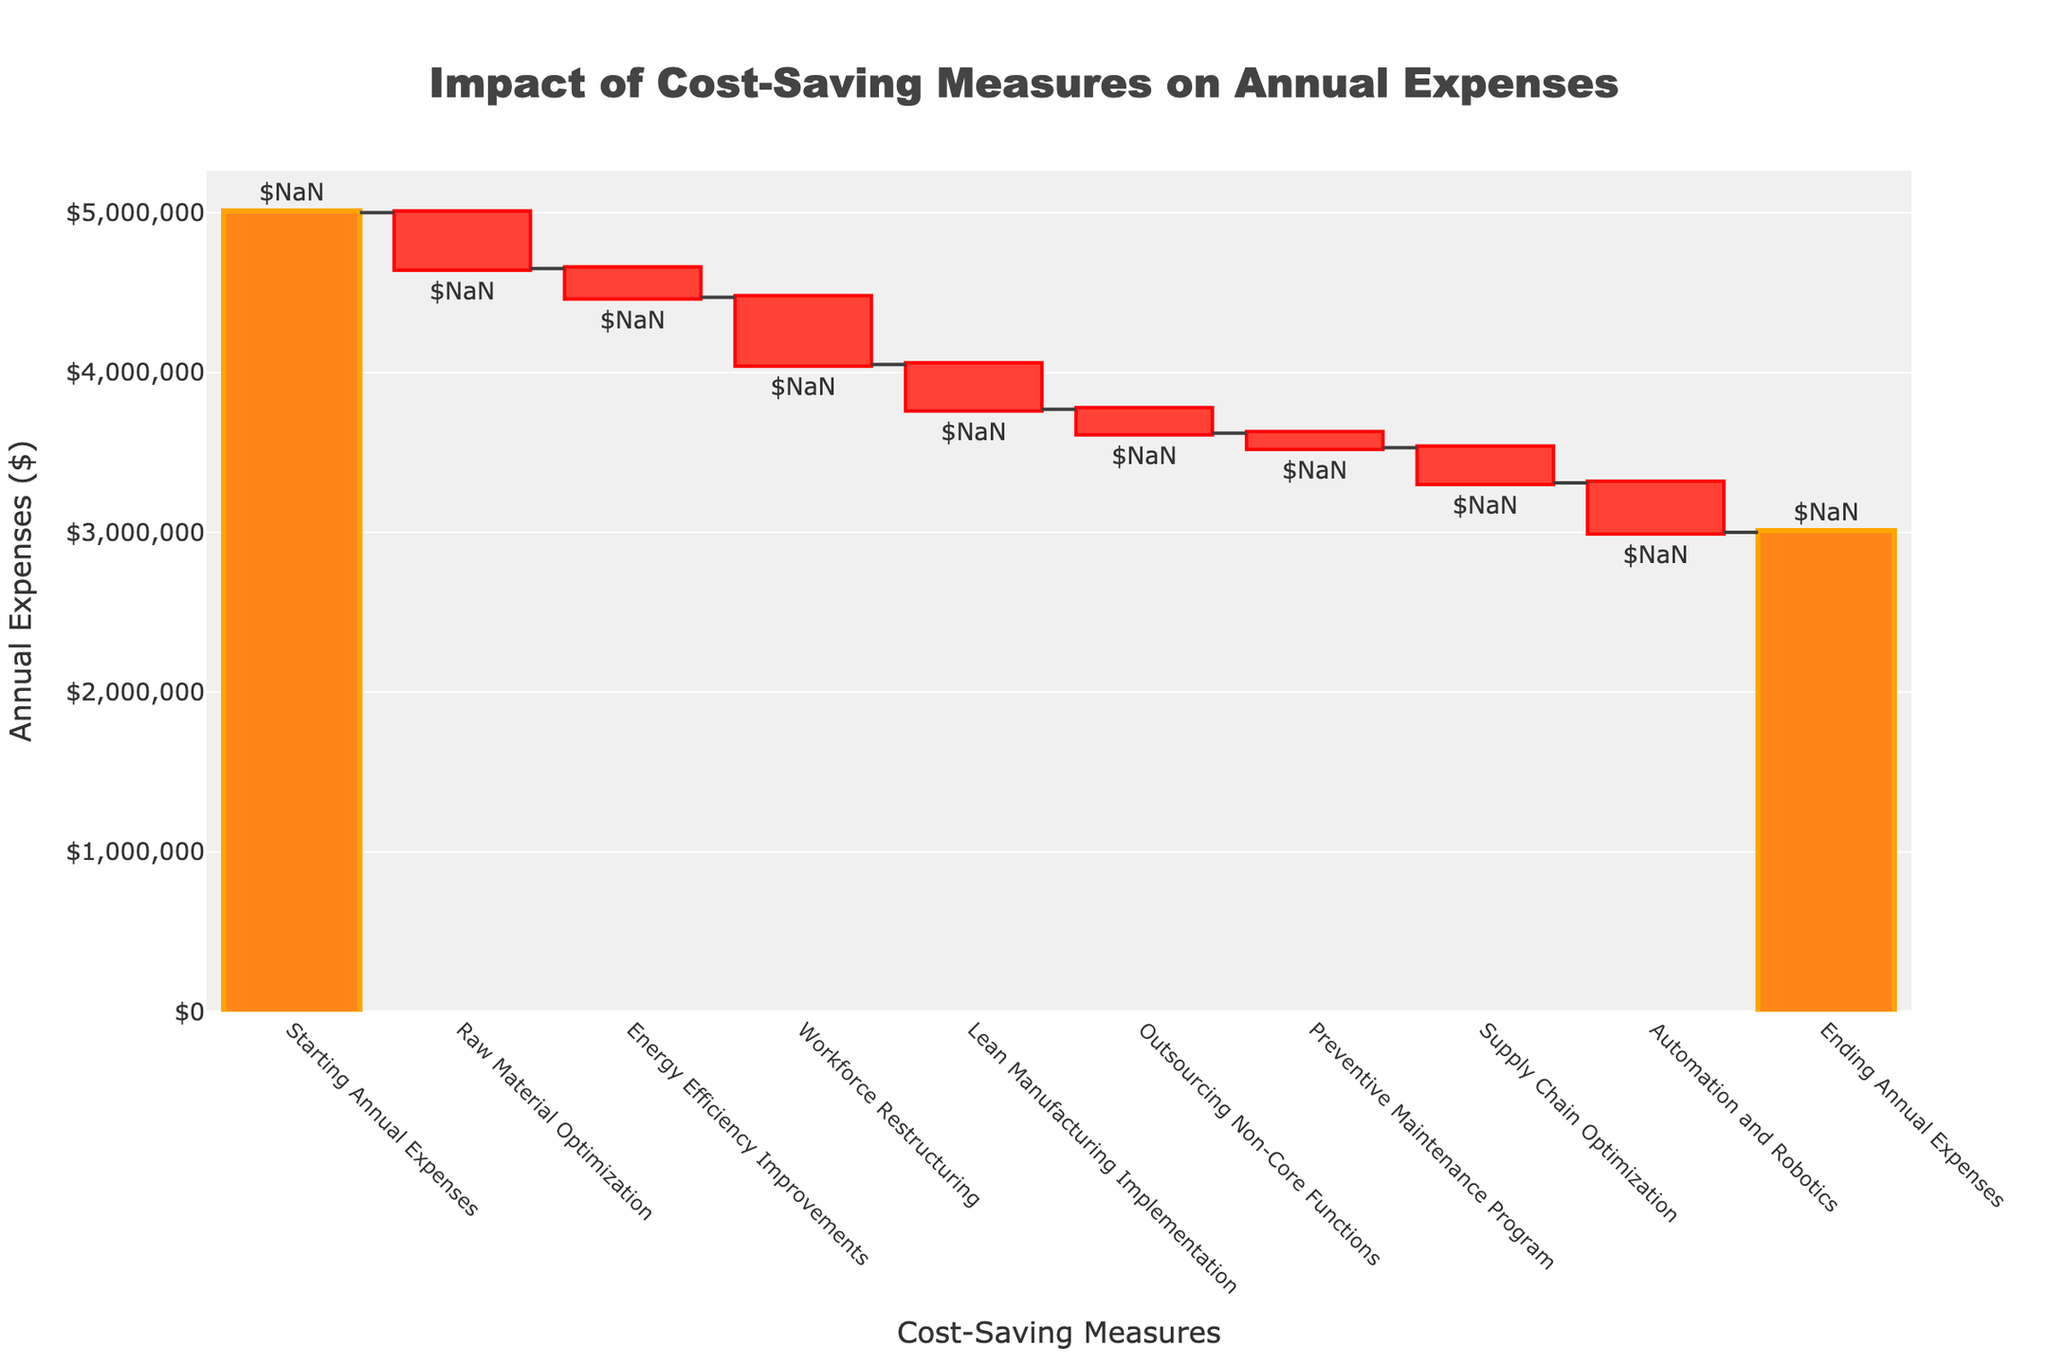what is the title of the chart? The chart title is typically placed at the top of the figure and specifies the purpose or content of the chart. In this case, the title as given is "Impact of Cost-Saving Measures on Annual Expenses."
Answer: "Impact of Cost-Saving Measures on Annual Expenses" What does the first bar represent? In Waterfall Charts, the first bar usually represents the starting value or initial amount, which in this case is titled "Starting Annual Expenses" and amounts to $5,000,000.
Answer: Starting Annual Expenses $5,000,000 Which cost-saving measure has the highest impact? To determine the highest impact, observe which bar has the largest negative value. "Raw Material Optimization" has the largest negative value with a reduction of $350,000.
Answer: Raw Material Optimization What is the total reduction in expenses due to "Energy Efficiency Improvements" and "Supply Chain Optimization"? Add the expenses reduced by "Energy Efficiency Improvements" ($180,000) and "Supply Chain Optimization" ($220,000).
Answer: $400,000 By how much did the "Automation and Robotics" measure reduce the annual expenses? The bar labeled "Automation and Robotics" shows a reduction in expenses. The exact amount noted is $310,000.
Answer: $310,000 How much are the Ending Annual Expenses represented by the last bar? The last bar represents the Ending Annual Expenses which, according to the figure, is $3,000,000.
Answer: $3,000,000 Are the total cost savings greater than or less than $2,000,000? Sum the values of all the negative contributions to see if they are greater than $2,000,000: -$350,000 - $180,000 - $420,000 - $280,000 - $150,000 - $90,000 - $220,000 - $310,000 = -$2,000,000. However, it's noted that cumulatively, the total cost-saving measures add up to reduce the expenses from $5,000,000 to $3,000,000, implying a total saving of $2,000,000.
Answer: $2,000,000 How many cost-saving measures are represented in the chart? Count the number of bars representing cost-saving measures. Exclude the starting and ending bars: Raw Material Optimization, Energy Efficiency Improvements, Workforce Restructuring, Lean Manufacturing Implementation, Outsourcing Non-Core Functions, Preventive Maintenance Program, Supply Chain Optimization, Automation and Robotics. There are 8 measures.
Answer: 8 How does "Lean Manufacturing Implementation" compare to "Outsourcing Non-Core Functions" in terms of cost savings? Compare the values of the cost-saving measures. "Lean Manufacturing Implementation" saved $280,000, whereas "Outsourcing Non-Core Functions" saved $150,000. Hence, "Lean Manufacturing Implementation" contributed more to savings.
Answer: Lean Manufacturing Implementation saved more 